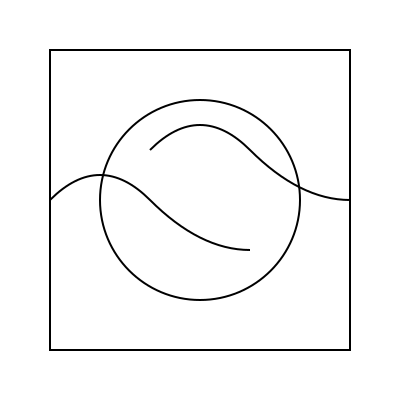In designing a logo for your boutique that combines fashion and pastry elements, which geometric shape would best represent the versatility of your business while maintaining a balanced and aesthetically pleasing composition? To design an effective logo that represents both fashion and pastry elements for the boutique, we need to consider the following steps:

1. Identify key elements:
   - Fashion: flowing lines, curves, elegance
   - Pastry: circular shapes, swirls, delicate details

2. Analyze geometric shapes:
   - Square: represents stability and professionalism
   - Circle: symbolizes unity and completeness
   - Curves: suggest fluidity and grace

3. Combine elements:
   - The square frame provides a stable foundation
   - The circle represents both a cake and a fashion accessory (e.g., hat, button)
   - Curves inside and outside the circle represent both icing swirls and fabric drapes

4. Consider balance:
   - The circular shape is centered within the square
   - Curves are distributed evenly on both sides

5. Ensure versatility:
   - The simple geometric shapes allow for easy scaling and reproduction
   - The design works well in both color and black-and-white

6. Reflect on symbolism:
   - The interplay between straight lines and curves represents the fusion of structure (fashion) and creativity (pastry)

Given these considerations, the circle within a square, combined with curved elements, best represents the versatility of the boutique while maintaining a balanced and aesthetically pleasing composition.
Answer: Circle within a square with curved elements 